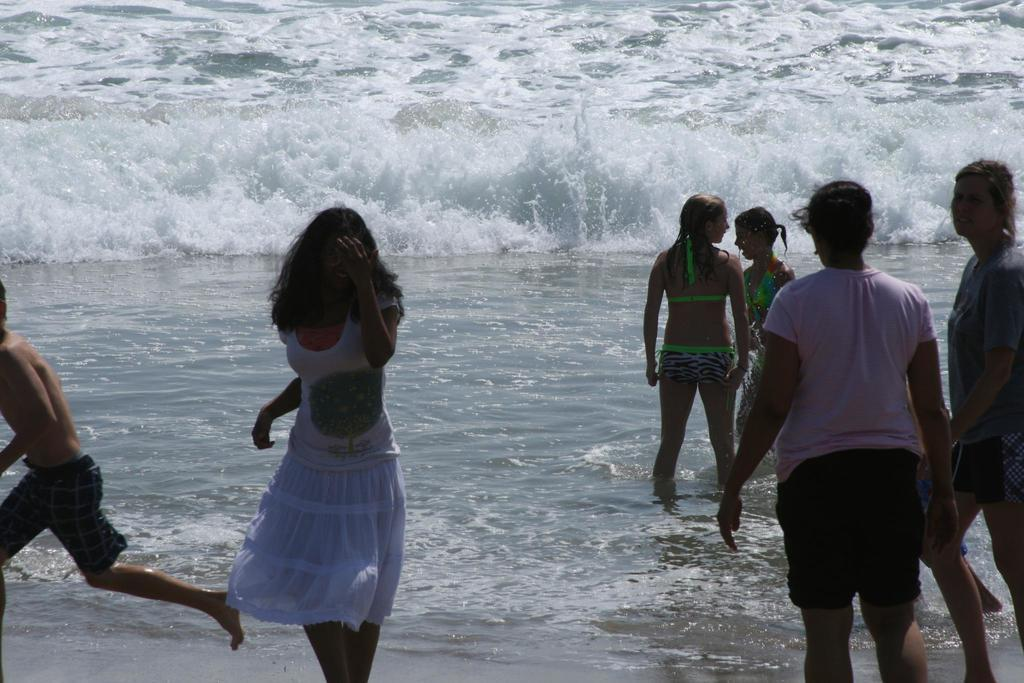How many people can be seen in the image? There are many people in the image. What natural element is visible in the image? There is water visible in the image. What characteristic of the water can be observed in the image? Waves are present in the water. What type of machine can be seen operating in the water in the image? There is no machine present in the water or in the image. What type of pen is being used by the people in the image? There is no pen visible in the image, as it features people and water with waves. 